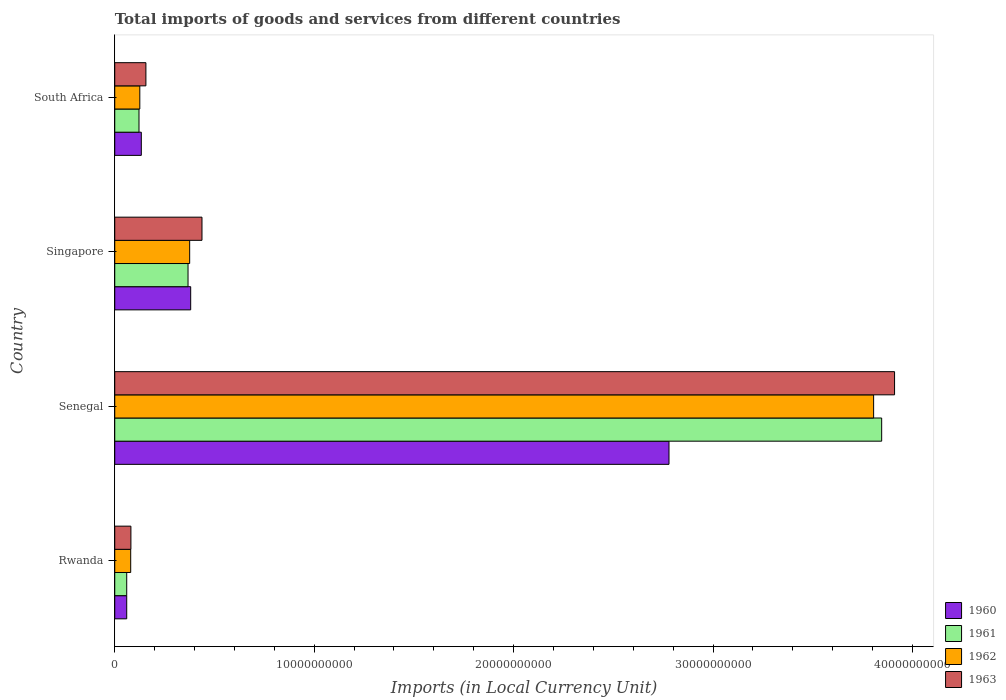How many bars are there on the 3rd tick from the top?
Your response must be concise. 4. What is the label of the 1st group of bars from the top?
Offer a terse response. South Africa. In how many cases, is the number of bars for a given country not equal to the number of legend labels?
Provide a short and direct response. 0. What is the Amount of goods and services imports in 1960 in Singapore?
Offer a very short reply. 3.81e+09. Across all countries, what is the maximum Amount of goods and services imports in 1960?
Give a very brief answer. 2.78e+1. Across all countries, what is the minimum Amount of goods and services imports in 1960?
Give a very brief answer. 6.00e+08. In which country was the Amount of goods and services imports in 1960 maximum?
Your answer should be compact. Senegal. In which country was the Amount of goods and services imports in 1963 minimum?
Give a very brief answer. Rwanda. What is the total Amount of goods and services imports in 1962 in the graph?
Your response must be concise. 4.39e+1. What is the difference between the Amount of goods and services imports in 1962 in Rwanda and that in South Africa?
Make the answer very short. -4.57e+08. What is the difference between the Amount of goods and services imports in 1962 in South Africa and the Amount of goods and services imports in 1961 in Singapore?
Your response must be concise. -2.42e+09. What is the average Amount of goods and services imports in 1960 per country?
Make the answer very short. 8.38e+09. What is the difference between the Amount of goods and services imports in 1963 and Amount of goods and services imports in 1962 in South Africa?
Ensure brevity in your answer.  3.06e+08. In how many countries, is the Amount of goods and services imports in 1961 greater than 36000000000 LCU?
Give a very brief answer. 1. What is the ratio of the Amount of goods and services imports in 1963 in Rwanda to that in South Africa?
Your answer should be compact. 0.52. What is the difference between the highest and the second highest Amount of goods and services imports in 1962?
Provide a succinct answer. 3.43e+1. What is the difference between the highest and the lowest Amount of goods and services imports in 1961?
Your response must be concise. 3.79e+1. In how many countries, is the Amount of goods and services imports in 1962 greater than the average Amount of goods and services imports in 1962 taken over all countries?
Give a very brief answer. 1. Is the sum of the Amount of goods and services imports in 1962 in Rwanda and Singapore greater than the maximum Amount of goods and services imports in 1961 across all countries?
Provide a short and direct response. No. What does the 4th bar from the bottom in Singapore represents?
Your response must be concise. 1963. How many bars are there?
Make the answer very short. 16. Are all the bars in the graph horizontal?
Keep it short and to the point. Yes. How many countries are there in the graph?
Provide a short and direct response. 4. What is the difference between two consecutive major ticks on the X-axis?
Offer a very short reply. 1.00e+1. Does the graph contain any zero values?
Provide a succinct answer. No. What is the title of the graph?
Provide a short and direct response. Total imports of goods and services from different countries. What is the label or title of the X-axis?
Make the answer very short. Imports (in Local Currency Unit). What is the label or title of the Y-axis?
Give a very brief answer. Country. What is the Imports (in Local Currency Unit) of 1960 in Rwanda?
Provide a succinct answer. 6.00e+08. What is the Imports (in Local Currency Unit) of 1961 in Rwanda?
Ensure brevity in your answer.  6.00e+08. What is the Imports (in Local Currency Unit) in 1962 in Rwanda?
Provide a short and direct response. 8.00e+08. What is the Imports (in Local Currency Unit) of 1963 in Rwanda?
Give a very brief answer. 8.10e+08. What is the Imports (in Local Currency Unit) of 1960 in Senegal?
Make the answer very short. 2.78e+1. What is the Imports (in Local Currency Unit) of 1961 in Senegal?
Give a very brief answer. 3.85e+1. What is the Imports (in Local Currency Unit) in 1962 in Senegal?
Your answer should be very brief. 3.81e+1. What is the Imports (in Local Currency Unit) in 1963 in Senegal?
Keep it short and to the point. 3.91e+1. What is the Imports (in Local Currency Unit) of 1960 in Singapore?
Provide a succinct answer. 3.81e+09. What is the Imports (in Local Currency Unit) in 1961 in Singapore?
Offer a very short reply. 3.67e+09. What is the Imports (in Local Currency Unit) in 1962 in Singapore?
Offer a terse response. 3.76e+09. What is the Imports (in Local Currency Unit) of 1963 in Singapore?
Make the answer very short. 4.37e+09. What is the Imports (in Local Currency Unit) in 1960 in South Africa?
Your answer should be very brief. 1.33e+09. What is the Imports (in Local Currency Unit) in 1961 in South Africa?
Offer a terse response. 1.22e+09. What is the Imports (in Local Currency Unit) of 1962 in South Africa?
Ensure brevity in your answer.  1.26e+09. What is the Imports (in Local Currency Unit) of 1963 in South Africa?
Your response must be concise. 1.56e+09. Across all countries, what is the maximum Imports (in Local Currency Unit) in 1960?
Provide a succinct answer. 2.78e+1. Across all countries, what is the maximum Imports (in Local Currency Unit) of 1961?
Your answer should be compact. 3.85e+1. Across all countries, what is the maximum Imports (in Local Currency Unit) in 1962?
Give a very brief answer. 3.81e+1. Across all countries, what is the maximum Imports (in Local Currency Unit) of 1963?
Your answer should be very brief. 3.91e+1. Across all countries, what is the minimum Imports (in Local Currency Unit) in 1960?
Your answer should be compact. 6.00e+08. Across all countries, what is the minimum Imports (in Local Currency Unit) in 1961?
Ensure brevity in your answer.  6.00e+08. Across all countries, what is the minimum Imports (in Local Currency Unit) of 1962?
Keep it short and to the point. 8.00e+08. Across all countries, what is the minimum Imports (in Local Currency Unit) in 1963?
Provide a short and direct response. 8.10e+08. What is the total Imports (in Local Currency Unit) in 1960 in the graph?
Provide a short and direct response. 3.35e+1. What is the total Imports (in Local Currency Unit) in 1961 in the graph?
Offer a very short reply. 4.39e+1. What is the total Imports (in Local Currency Unit) of 1962 in the graph?
Offer a very short reply. 4.39e+1. What is the total Imports (in Local Currency Unit) of 1963 in the graph?
Your answer should be very brief. 4.58e+1. What is the difference between the Imports (in Local Currency Unit) of 1960 in Rwanda and that in Senegal?
Give a very brief answer. -2.72e+1. What is the difference between the Imports (in Local Currency Unit) of 1961 in Rwanda and that in Senegal?
Offer a terse response. -3.79e+1. What is the difference between the Imports (in Local Currency Unit) in 1962 in Rwanda and that in Senegal?
Make the answer very short. -3.73e+1. What is the difference between the Imports (in Local Currency Unit) of 1963 in Rwanda and that in Senegal?
Keep it short and to the point. -3.83e+1. What is the difference between the Imports (in Local Currency Unit) of 1960 in Rwanda and that in Singapore?
Your answer should be compact. -3.21e+09. What is the difference between the Imports (in Local Currency Unit) of 1961 in Rwanda and that in Singapore?
Your answer should be compact. -3.07e+09. What is the difference between the Imports (in Local Currency Unit) in 1962 in Rwanda and that in Singapore?
Provide a succinct answer. -2.96e+09. What is the difference between the Imports (in Local Currency Unit) of 1963 in Rwanda and that in Singapore?
Keep it short and to the point. -3.56e+09. What is the difference between the Imports (in Local Currency Unit) in 1960 in Rwanda and that in South Africa?
Your response must be concise. -7.32e+08. What is the difference between the Imports (in Local Currency Unit) of 1961 in Rwanda and that in South Africa?
Your response must be concise. -6.16e+08. What is the difference between the Imports (in Local Currency Unit) in 1962 in Rwanda and that in South Africa?
Your response must be concise. -4.57e+08. What is the difference between the Imports (in Local Currency Unit) in 1963 in Rwanda and that in South Africa?
Your answer should be compact. -7.52e+08. What is the difference between the Imports (in Local Currency Unit) in 1960 in Senegal and that in Singapore?
Offer a very short reply. 2.40e+1. What is the difference between the Imports (in Local Currency Unit) in 1961 in Senegal and that in Singapore?
Offer a very short reply. 3.48e+1. What is the difference between the Imports (in Local Currency Unit) in 1962 in Senegal and that in Singapore?
Give a very brief answer. 3.43e+1. What is the difference between the Imports (in Local Currency Unit) in 1963 in Senegal and that in Singapore?
Keep it short and to the point. 3.47e+1. What is the difference between the Imports (in Local Currency Unit) in 1960 in Senegal and that in South Africa?
Provide a succinct answer. 2.65e+1. What is the difference between the Imports (in Local Currency Unit) in 1961 in Senegal and that in South Africa?
Offer a terse response. 3.72e+1. What is the difference between the Imports (in Local Currency Unit) in 1962 in Senegal and that in South Africa?
Provide a succinct answer. 3.68e+1. What is the difference between the Imports (in Local Currency Unit) of 1963 in Senegal and that in South Africa?
Your answer should be compact. 3.75e+1. What is the difference between the Imports (in Local Currency Unit) in 1960 in Singapore and that in South Africa?
Make the answer very short. 2.48e+09. What is the difference between the Imports (in Local Currency Unit) of 1961 in Singapore and that in South Africa?
Provide a short and direct response. 2.46e+09. What is the difference between the Imports (in Local Currency Unit) of 1962 in Singapore and that in South Africa?
Provide a short and direct response. 2.50e+09. What is the difference between the Imports (in Local Currency Unit) of 1963 in Singapore and that in South Africa?
Provide a short and direct response. 2.81e+09. What is the difference between the Imports (in Local Currency Unit) in 1960 in Rwanda and the Imports (in Local Currency Unit) in 1961 in Senegal?
Your answer should be very brief. -3.79e+1. What is the difference between the Imports (in Local Currency Unit) in 1960 in Rwanda and the Imports (in Local Currency Unit) in 1962 in Senegal?
Make the answer very short. -3.75e+1. What is the difference between the Imports (in Local Currency Unit) of 1960 in Rwanda and the Imports (in Local Currency Unit) of 1963 in Senegal?
Your answer should be very brief. -3.85e+1. What is the difference between the Imports (in Local Currency Unit) of 1961 in Rwanda and the Imports (in Local Currency Unit) of 1962 in Senegal?
Keep it short and to the point. -3.75e+1. What is the difference between the Imports (in Local Currency Unit) of 1961 in Rwanda and the Imports (in Local Currency Unit) of 1963 in Senegal?
Offer a terse response. -3.85e+1. What is the difference between the Imports (in Local Currency Unit) of 1962 in Rwanda and the Imports (in Local Currency Unit) of 1963 in Senegal?
Offer a terse response. -3.83e+1. What is the difference between the Imports (in Local Currency Unit) of 1960 in Rwanda and the Imports (in Local Currency Unit) of 1961 in Singapore?
Offer a very short reply. -3.07e+09. What is the difference between the Imports (in Local Currency Unit) in 1960 in Rwanda and the Imports (in Local Currency Unit) in 1962 in Singapore?
Give a very brief answer. -3.16e+09. What is the difference between the Imports (in Local Currency Unit) of 1960 in Rwanda and the Imports (in Local Currency Unit) of 1963 in Singapore?
Offer a very short reply. -3.77e+09. What is the difference between the Imports (in Local Currency Unit) in 1961 in Rwanda and the Imports (in Local Currency Unit) in 1962 in Singapore?
Keep it short and to the point. -3.16e+09. What is the difference between the Imports (in Local Currency Unit) in 1961 in Rwanda and the Imports (in Local Currency Unit) in 1963 in Singapore?
Provide a succinct answer. -3.77e+09. What is the difference between the Imports (in Local Currency Unit) in 1962 in Rwanda and the Imports (in Local Currency Unit) in 1963 in Singapore?
Keep it short and to the point. -3.57e+09. What is the difference between the Imports (in Local Currency Unit) in 1960 in Rwanda and the Imports (in Local Currency Unit) in 1961 in South Africa?
Your answer should be very brief. -6.16e+08. What is the difference between the Imports (in Local Currency Unit) of 1960 in Rwanda and the Imports (in Local Currency Unit) of 1962 in South Africa?
Provide a succinct answer. -6.57e+08. What is the difference between the Imports (in Local Currency Unit) in 1960 in Rwanda and the Imports (in Local Currency Unit) in 1963 in South Africa?
Make the answer very short. -9.62e+08. What is the difference between the Imports (in Local Currency Unit) of 1961 in Rwanda and the Imports (in Local Currency Unit) of 1962 in South Africa?
Keep it short and to the point. -6.57e+08. What is the difference between the Imports (in Local Currency Unit) of 1961 in Rwanda and the Imports (in Local Currency Unit) of 1963 in South Africa?
Provide a short and direct response. -9.62e+08. What is the difference between the Imports (in Local Currency Unit) of 1962 in Rwanda and the Imports (in Local Currency Unit) of 1963 in South Africa?
Provide a short and direct response. -7.62e+08. What is the difference between the Imports (in Local Currency Unit) in 1960 in Senegal and the Imports (in Local Currency Unit) in 1961 in Singapore?
Make the answer very short. 2.41e+1. What is the difference between the Imports (in Local Currency Unit) in 1960 in Senegal and the Imports (in Local Currency Unit) in 1962 in Singapore?
Make the answer very short. 2.40e+1. What is the difference between the Imports (in Local Currency Unit) of 1960 in Senegal and the Imports (in Local Currency Unit) of 1963 in Singapore?
Offer a terse response. 2.34e+1. What is the difference between the Imports (in Local Currency Unit) in 1961 in Senegal and the Imports (in Local Currency Unit) in 1962 in Singapore?
Your answer should be compact. 3.47e+1. What is the difference between the Imports (in Local Currency Unit) of 1961 in Senegal and the Imports (in Local Currency Unit) of 1963 in Singapore?
Your response must be concise. 3.41e+1. What is the difference between the Imports (in Local Currency Unit) of 1962 in Senegal and the Imports (in Local Currency Unit) of 1963 in Singapore?
Keep it short and to the point. 3.37e+1. What is the difference between the Imports (in Local Currency Unit) in 1960 in Senegal and the Imports (in Local Currency Unit) in 1961 in South Africa?
Your answer should be compact. 2.66e+1. What is the difference between the Imports (in Local Currency Unit) in 1960 in Senegal and the Imports (in Local Currency Unit) in 1962 in South Africa?
Your answer should be very brief. 2.65e+1. What is the difference between the Imports (in Local Currency Unit) of 1960 in Senegal and the Imports (in Local Currency Unit) of 1963 in South Africa?
Give a very brief answer. 2.62e+1. What is the difference between the Imports (in Local Currency Unit) of 1961 in Senegal and the Imports (in Local Currency Unit) of 1962 in South Africa?
Your answer should be compact. 3.72e+1. What is the difference between the Imports (in Local Currency Unit) of 1961 in Senegal and the Imports (in Local Currency Unit) of 1963 in South Africa?
Your response must be concise. 3.69e+1. What is the difference between the Imports (in Local Currency Unit) of 1962 in Senegal and the Imports (in Local Currency Unit) of 1963 in South Africa?
Your answer should be compact. 3.65e+1. What is the difference between the Imports (in Local Currency Unit) in 1960 in Singapore and the Imports (in Local Currency Unit) in 1961 in South Africa?
Keep it short and to the point. 2.59e+09. What is the difference between the Imports (in Local Currency Unit) in 1960 in Singapore and the Imports (in Local Currency Unit) in 1962 in South Africa?
Your answer should be very brief. 2.55e+09. What is the difference between the Imports (in Local Currency Unit) in 1960 in Singapore and the Imports (in Local Currency Unit) in 1963 in South Africa?
Ensure brevity in your answer.  2.25e+09. What is the difference between the Imports (in Local Currency Unit) in 1961 in Singapore and the Imports (in Local Currency Unit) in 1962 in South Africa?
Your answer should be compact. 2.42e+09. What is the difference between the Imports (in Local Currency Unit) of 1961 in Singapore and the Imports (in Local Currency Unit) of 1963 in South Africa?
Your response must be concise. 2.11e+09. What is the difference between the Imports (in Local Currency Unit) of 1962 in Singapore and the Imports (in Local Currency Unit) of 1963 in South Africa?
Keep it short and to the point. 2.19e+09. What is the average Imports (in Local Currency Unit) of 1960 per country?
Offer a very short reply. 8.38e+09. What is the average Imports (in Local Currency Unit) in 1961 per country?
Keep it short and to the point. 1.10e+1. What is the average Imports (in Local Currency Unit) of 1962 per country?
Offer a terse response. 1.10e+1. What is the average Imports (in Local Currency Unit) of 1963 per country?
Provide a short and direct response. 1.15e+1. What is the difference between the Imports (in Local Currency Unit) in 1960 and Imports (in Local Currency Unit) in 1962 in Rwanda?
Your response must be concise. -2.00e+08. What is the difference between the Imports (in Local Currency Unit) in 1960 and Imports (in Local Currency Unit) in 1963 in Rwanda?
Provide a succinct answer. -2.10e+08. What is the difference between the Imports (in Local Currency Unit) in 1961 and Imports (in Local Currency Unit) in 1962 in Rwanda?
Offer a terse response. -2.00e+08. What is the difference between the Imports (in Local Currency Unit) in 1961 and Imports (in Local Currency Unit) in 1963 in Rwanda?
Make the answer very short. -2.10e+08. What is the difference between the Imports (in Local Currency Unit) in 1962 and Imports (in Local Currency Unit) in 1963 in Rwanda?
Provide a short and direct response. -1.00e+07. What is the difference between the Imports (in Local Currency Unit) of 1960 and Imports (in Local Currency Unit) of 1961 in Senegal?
Give a very brief answer. -1.07e+1. What is the difference between the Imports (in Local Currency Unit) of 1960 and Imports (in Local Currency Unit) of 1962 in Senegal?
Provide a short and direct response. -1.03e+1. What is the difference between the Imports (in Local Currency Unit) of 1960 and Imports (in Local Currency Unit) of 1963 in Senegal?
Your answer should be compact. -1.13e+1. What is the difference between the Imports (in Local Currency Unit) in 1961 and Imports (in Local Currency Unit) in 1962 in Senegal?
Your answer should be compact. 4.04e+08. What is the difference between the Imports (in Local Currency Unit) in 1961 and Imports (in Local Currency Unit) in 1963 in Senegal?
Your answer should be compact. -6.46e+08. What is the difference between the Imports (in Local Currency Unit) of 1962 and Imports (in Local Currency Unit) of 1963 in Senegal?
Give a very brief answer. -1.05e+09. What is the difference between the Imports (in Local Currency Unit) of 1960 and Imports (in Local Currency Unit) of 1961 in Singapore?
Give a very brief answer. 1.33e+08. What is the difference between the Imports (in Local Currency Unit) in 1960 and Imports (in Local Currency Unit) in 1962 in Singapore?
Provide a short and direct response. 5.08e+07. What is the difference between the Imports (in Local Currency Unit) of 1960 and Imports (in Local Currency Unit) of 1963 in Singapore?
Ensure brevity in your answer.  -5.67e+08. What is the difference between the Imports (in Local Currency Unit) in 1961 and Imports (in Local Currency Unit) in 1962 in Singapore?
Offer a terse response. -8.22e+07. What is the difference between the Imports (in Local Currency Unit) in 1961 and Imports (in Local Currency Unit) in 1963 in Singapore?
Keep it short and to the point. -7.00e+08. What is the difference between the Imports (in Local Currency Unit) of 1962 and Imports (in Local Currency Unit) of 1963 in Singapore?
Offer a terse response. -6.18e+08. What is the difference between the Imports (in Local Currency Unit) of 1960 and Imports (in Local Currency Unit) of 1961 in South Africa?
Give a very brief answer. 1.16e+08. What is the difference between the Imports (in Local Currency Unit) in 1960 and Imports (in Local Currency Unit) in 1962 in South Africa?
Give a very brief answer. 7.51e+07. What is the difference between the Imports (in Local Currency Unit) of 1960 and Imports (in Local Currency Unit) of 1963 in South Africa?
Provide a succinct answer. -2.30e+08. What is the difference between the Imports (in Local Currency Unit) of 1961 and Imports (in Local Currency Unit) of 1962 in South Africa?
Keep it short and to the point. -4.06e+07. What is the difference between the Imports (in Local Currency Unit) of 1961 and Imports (in Local Currency Unit) of 1963 in South Africa?
Your answer should be compact. -3.46e+08. What is the difference between the Imports (in Local Currency Unit) of 1962 and Imports (in Local Currency Unit) of 1963 in South Africa?
Your answer should be very brief. -3.06e+08. What is the ratio of the Imports (in Local Currency Unit) of 1960 in Rwanda to that in Senegal?
Give a very brief answer. 0.02. What is the ratio of the Imports (in Local Currency Unit) of 1961 in Rwanda to that in Senegal?
Make the answer very short. 0.02. What is the ratio of the Imports (in Local Currency Unit) in 1962 in Rwanda to that in Senegal?
Offer a very short reply. 0.02. What is the ratio of the Imports (in Local Currency Unit) of 1963 in Rwanda to that in Senegal?
Give a very brief answer. 0.02. What is the ratio of the Imports (in Local Currency Unit) in 1960 in Rwanda to that in Singapore?
Ensure brevity in your answer.  0.16. What is the ratio of the Imports (in Local Currency Unit) of 1961 in Rwanda to that in Singapore?
Your answer should be very brief. 0.16. What is the ratio of the Imports (in Local Currency Unit) of 1962 in Rwanda to that in Singapore?
Your response must be concise. 0.21. What is the ratio of the Imports (in Local Currency Unit) of 1963 in Rwanda to that in Singapore?
Your response must be concise. 0.19. What is the ratio of the Imports (in Local Currency Unit) of 1960 in Rwanda to that in South Africa?
Offer a terse response. 0.45. What is the ratio of the Imports (in Local Currency Unit) in 1961 in Rwanda to that in South Africa?
Provide a short and direct response. 0.49. What is the ratio of the Imports (in Local Currency Unit) in 1962 in Rwanda to that in South Africa?
Ensure brevity in your answer.  0.64. What is the ratio of the Imports (in Local Currency Unit) in 1963 in Rwanda to that in South Africa?
Offer a very short reply. 0.52. What is the ratio of the Imports (in Local Currency Unit) of 1960 in Senegal to that in Singapore?
Offer a very short reply. 7.3. What is the ratio of the Imports (in Local Currency Unit) in 1961 in Senegal to that in Singapore?
Your response must be concise. 10.47. What is the ratio of the Imports (in Local Currency Unit) of 1962 in Senegal to that in Singapore?
Offer a very short reply. 10.13. What is the ratio of the Imports (in Local Currency Unit) in 1963 in Senegal to that in Singapore?
Provide a short and direct response. 8.94. What is the ratio of the Imports (in Local Currency Unit) in 1960 in Senegal to that in South Africa?
Give a very brief answer. 20.87. What is the ratio of the Imports (in Local Currency Unit) in 1961 in Senegal to that in South Africa?
Your response must be concise. 31.63. What is the ratio of the Imports (in Local Currency Unit) in 1962 in Senegal to that in South Africa?
Provide a succinct answer. 30.28. What is the ratio of the Imports (in Local Currency Unit) of 1963 in Senegal to that in South Africa?
Offer a terse response. 25.03. What is the ratio of the Imports (in Local Currency Unit) in 1960 in Singapore to that in South Africa?
Give a very brief answer. 2.86. What is the ratio of the Imports (in Local Currency Unit) in 1961 in Singapore to that in South Africa?
Offer a terse response. 3.02. What is the ratio of the Imports (in Local Currency Unit) of 1962 in Singapore to that in South Africa?
Your answer should be compact. 2.99. What is the ratio of the Imports (in Local Currency Unit) of 1963 in Singapore to that in South Africa?
Give a very brief answer. 2.8. What is the difference between the highest and the second highest Imports (in Local Currency Unit) of 1960?
Ensure brevity in your answer.  2.40e+1. What is the difference between the highest and the second highest Imports (in Local Currency Unit) in 1961?
Your answer should be compact. 3.48e+1. What is the difference between the highest and the second highest Imports (in Local Currency Unit) of 1962?
Provide a short and direct response. 3.43e+1. What is the difference between the highest and the second highest Imports (in Local Currency Unit) of 1963?
Offer a terse response. 3.47e+1. What is the difference between the highest and the lowest Imports (in Local Currency Unit) of 1960?
Your response must be concise. 2.72e+1. What is the difference between the highest and the lowest Imports (in Local Currency Unit) of 1961?
Your answer should be compact. 3.79e+1. What is the difference between the highest and the lowest Imports (in Local Currency Unit) of 1962?
Your answer should be compact. 3.73e+1. What is the difference between the highest and the lowest Imports (in Local Currency Unit) of 1963?
Offer a very short reply. 3.83e+1. 